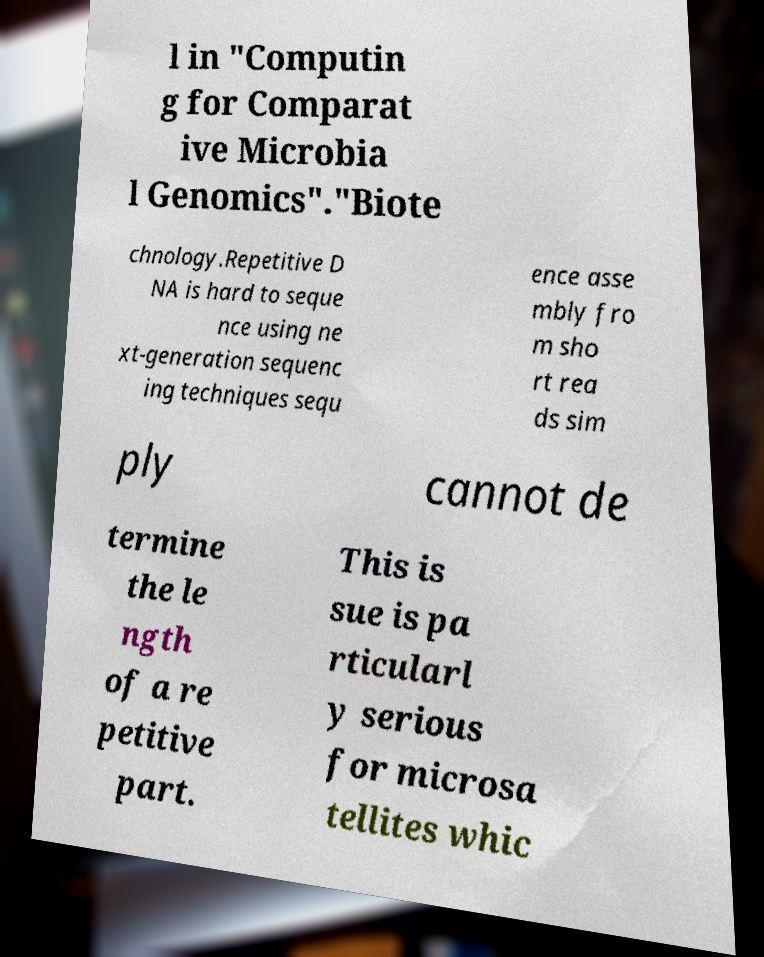Could you extract and type out the text from this image? l in "Computin g for Comparat ive Microbia l Genomics"."Biote chnology.Repetitive D NA is hard to seque nce using ne xt-generation sequenc ing techniques sequ ence asse mbly fro m sho rt rea ds sim ply cannot de termine the le ngth of a re petitive part. This is sue is pa rticularl y serious for microsa tellites whic 